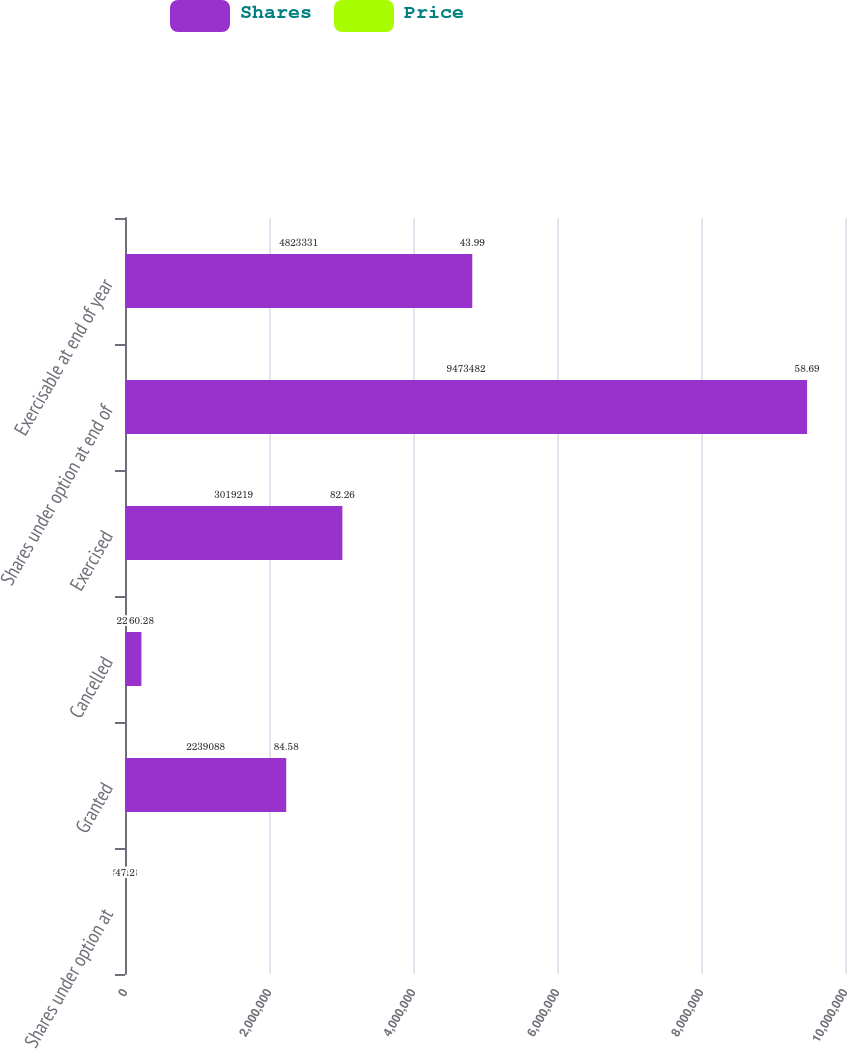Convert chart. <chart><loc_0><loc_0><loc_500><loc_500><stacked_bar_chart><ecel><fcel>Shares under option at<fcel>Granted<fcel>Cancelled<fcel>Exercised<fcel>Shares under option at end of<fcel>Exercisable at end of year<nl><fcel>Shares<fcel>84.58<fcel>2.23909e+06<fcel>228137<fcel>3.01922e+06<fcel>9.47348e+06<fcel>4.82333e+06<nl><fcel>Price<fcel>47.2<fcel>84.58<fcel>60.28<fcel>82.26<fcel>58.69<fcel>43.99<nl></chart> 